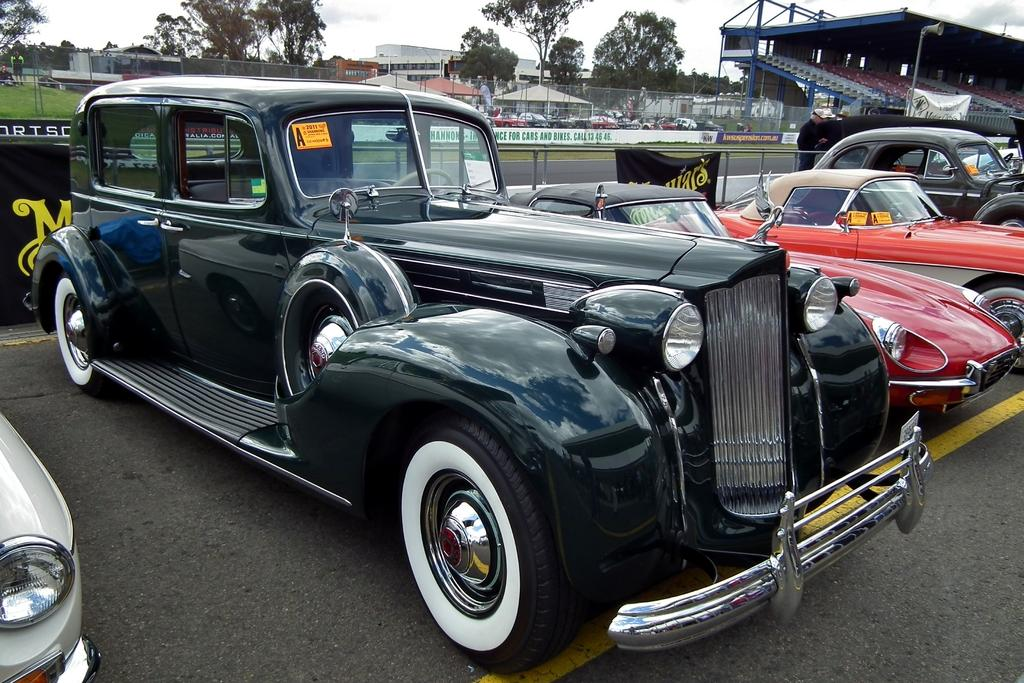What can be seen on the road in the image? There are many cars on the road in the image. What is located in the background of the image? There is a track with tents in the background of the image. What type of vegetation is visible in the background of the image? There are trees visible in the background of the image. What is visible above the trees in the image? The sky is visible above the trees in the image. How many apples are hanging from the trees in the image? There are no apples visible in the image; only trees are present in the background. What type of wood is used to construct the cars in the image? The cars in the image are not made of wood; they are likely made of metal or other materials. 